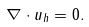<formula> <loc_0><loc_0><loc_500><loc_500>\nabla \cdot u _ { h } = 0 .</formula> 